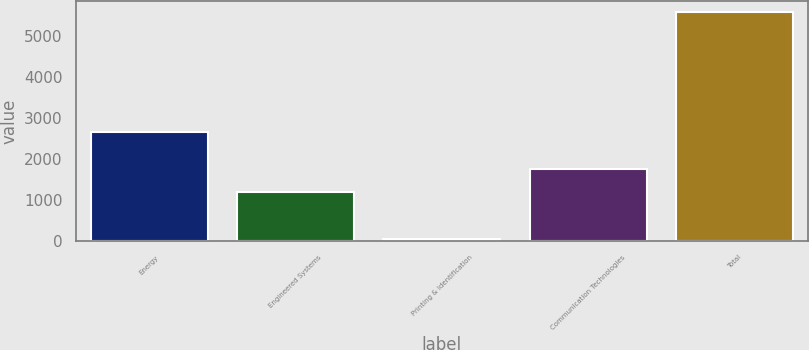Convert chart to OTSL. <chart><loc_0><loc_0><loc_500><loc_500><bar_chart><fcel>Energy<fcel>Engineered Systems<fcel>Printing & Identification<fcel>Communication Technologies<fcel>Total<nl><fcel>2668<fcel>1193<fcel>38<fcel>1747.5<fcel>5583<nl></chart> 